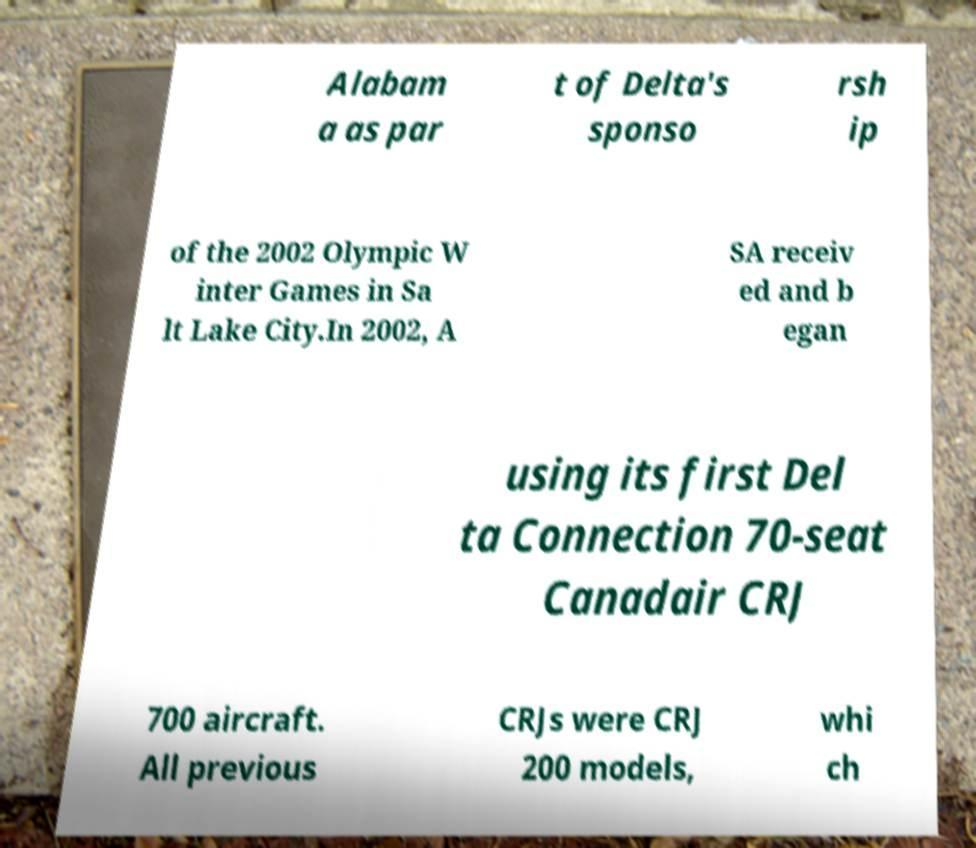Please read and relay the text visible in this image. What does it say? Alabam a as par t of Delta's sponso rsh ip of the 2002 Olympic W inter Games in Sa lt Lake City.In 2002, A SA receiv ed and b egan using its first Del ta Connection 70-seat Canadair CRJ 700 aircraft. All previous CRJs were CRJ 200 models, whi ch 